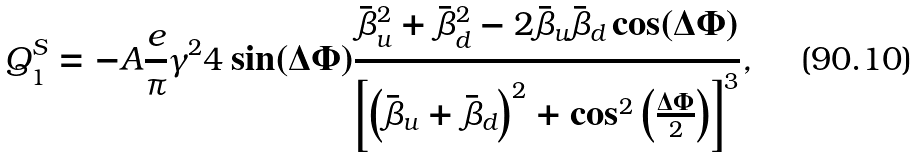Convert formula to latex. <formula><loc_0><loc_0><loc_500><loc_500>Q _ { 1 } ^ { \text {S} } = - A \frac { e } { \pi } \gamma ^ { 2 } 4 \sin ( \Delta \Phi ) \frac { \bar { \beta } _ { \text {u} } ^ { 2 } + \bar { \beta } _ { \text {d} } ^ { 2 } - 2 \bar { \beta } _ { \text {u} } \bar { \beta } _ { \text {d} } \cos ( \Delta \Phi ) } { \left [ \left ( \bar { \beta } _ { \text {u} } + \bar { \beta } _ { \text {d} } \right ) ^ { 2 } + \cos ^ { 2 } \left ( \frac { \Delta \Phi } { 2 } \right ) \right ] ^ { 3 } } ,</formula> 